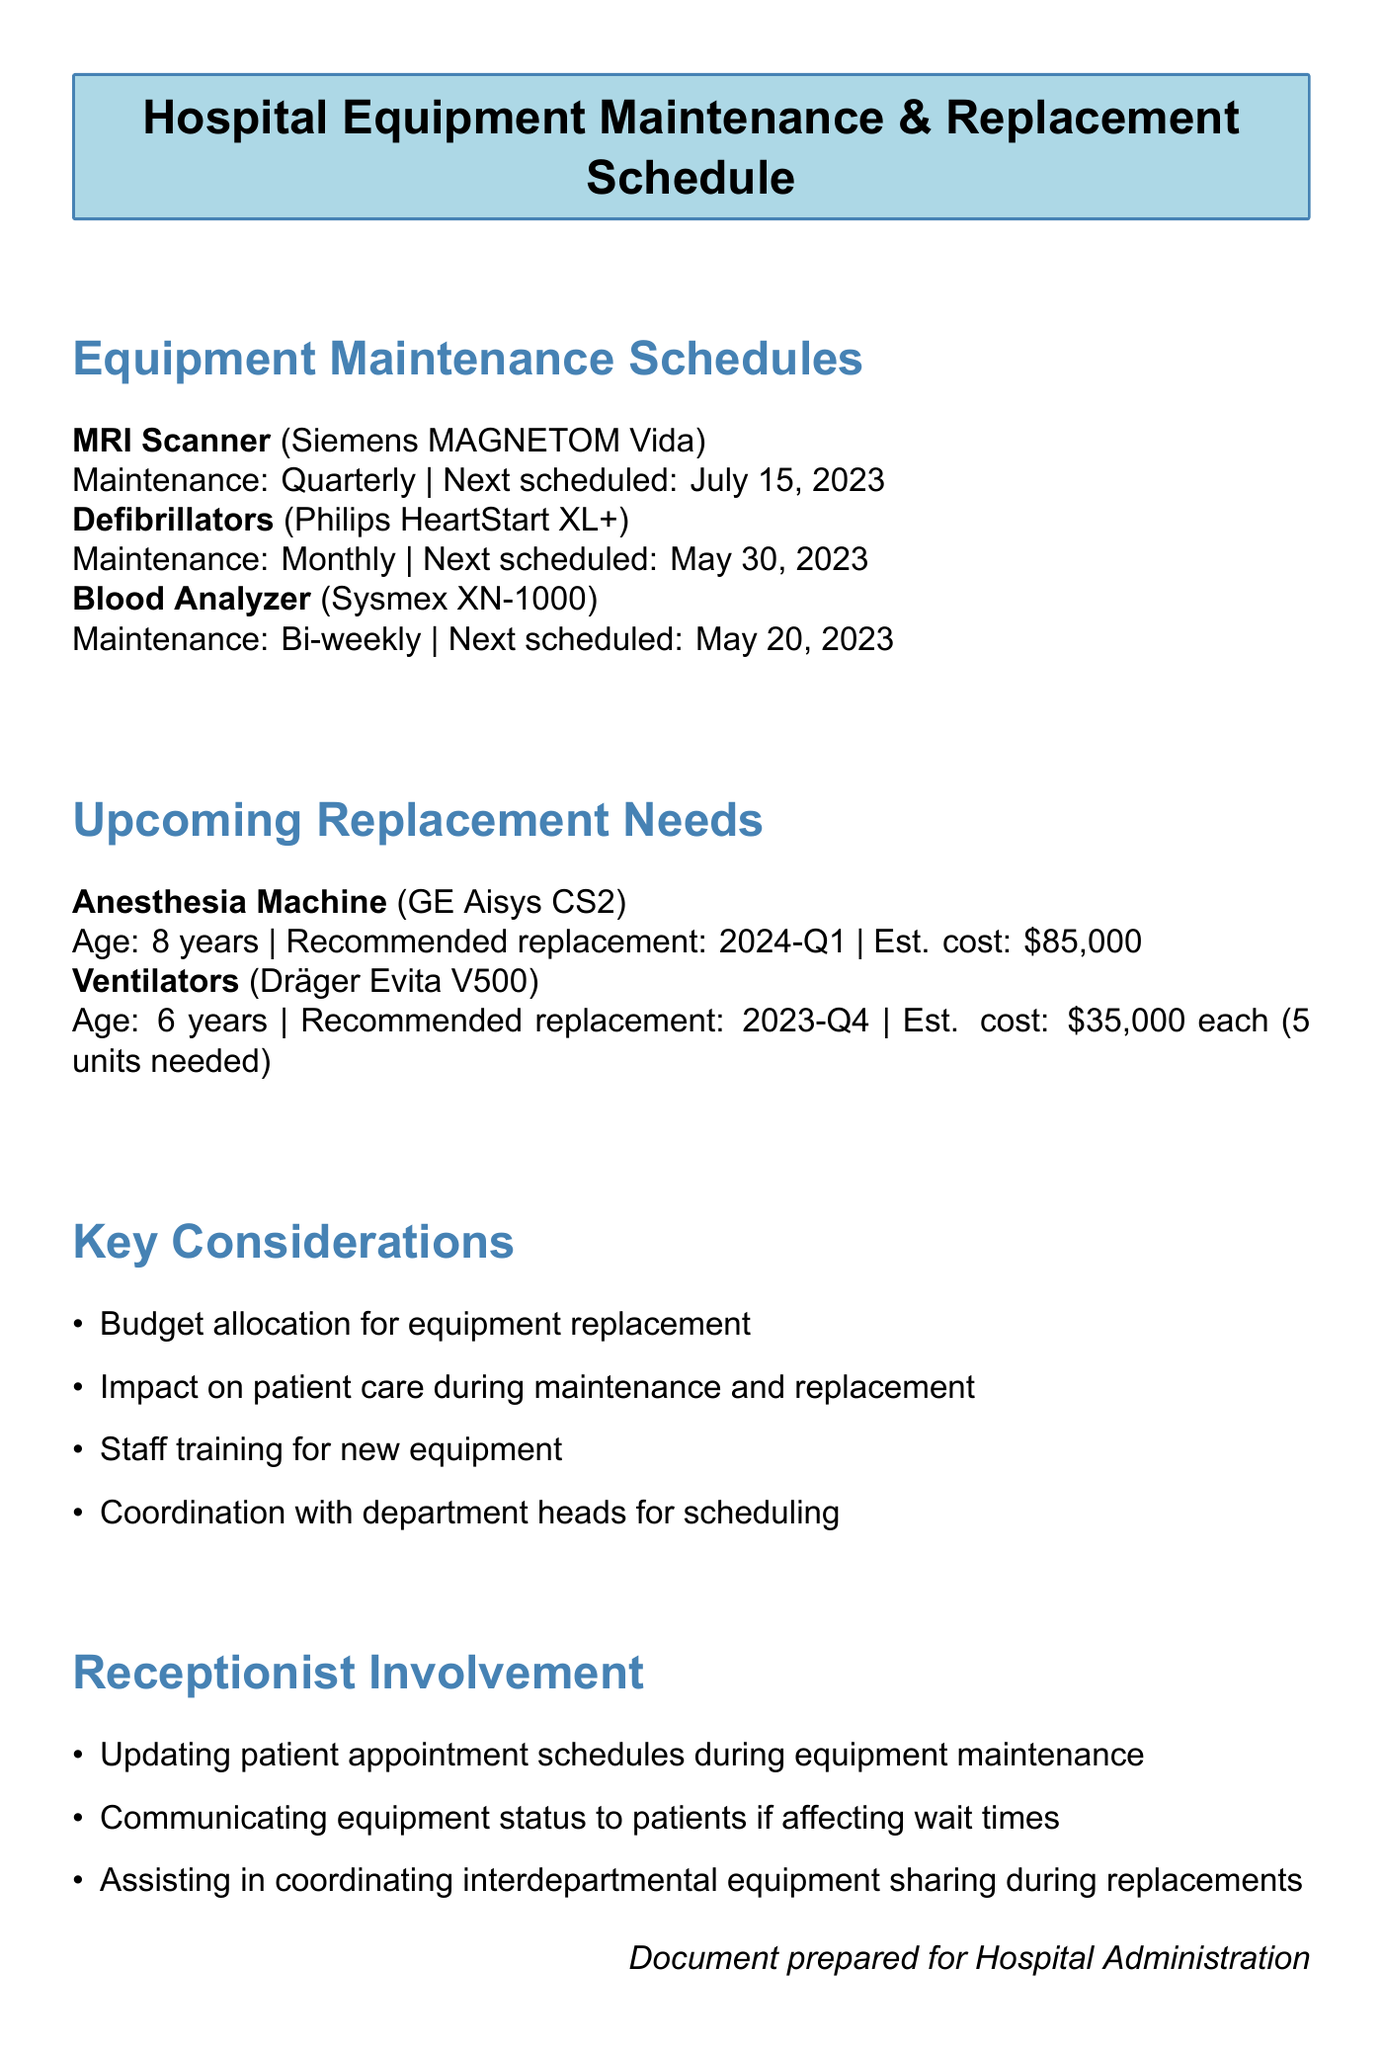What is the next scheduled maintenance date for the MRI Scanner? The next scheduled maintenance date is provided in the maintenance schedule for the MRI Scanner.
Answer: July 15, 2023 How often is the maintenance scheduled for Defibrillators? The maintenance frequency for Defibrillators can be found in the equipment maintenance schedules section.
Answer: Monthly What is the current age of the Anesthesia Machine? The current age is listed in the upcoming replacement needs for the Anesthesia Machine.
Answer: 8 years What is the estimated cost for one Ventilator? The estimated cost for Ventilators is detailed in the upcoming replacement needs section.
Answer: $35,000 each What key consideration relates to staff? The document specifies key considerations, one of which relates to staff training for new equipment.
Answer: Staff training for new equipment How many units of Ventilators are needed for replacement? The number of units needed is mentioned in the upcoming replacement needs for Ventilators.
Answer: 5 units needed What is the department responsible for the Blood Analyzer? The department responsible for the Blood Analyzer is included in the maintenance schedules.
Answer: Laboratory What type of document is this? The nature of the document is indicated in the title and includes maintenance and replacement schedules.
Answer: Hospital Equipment Maintenance & Replacement Schedule 